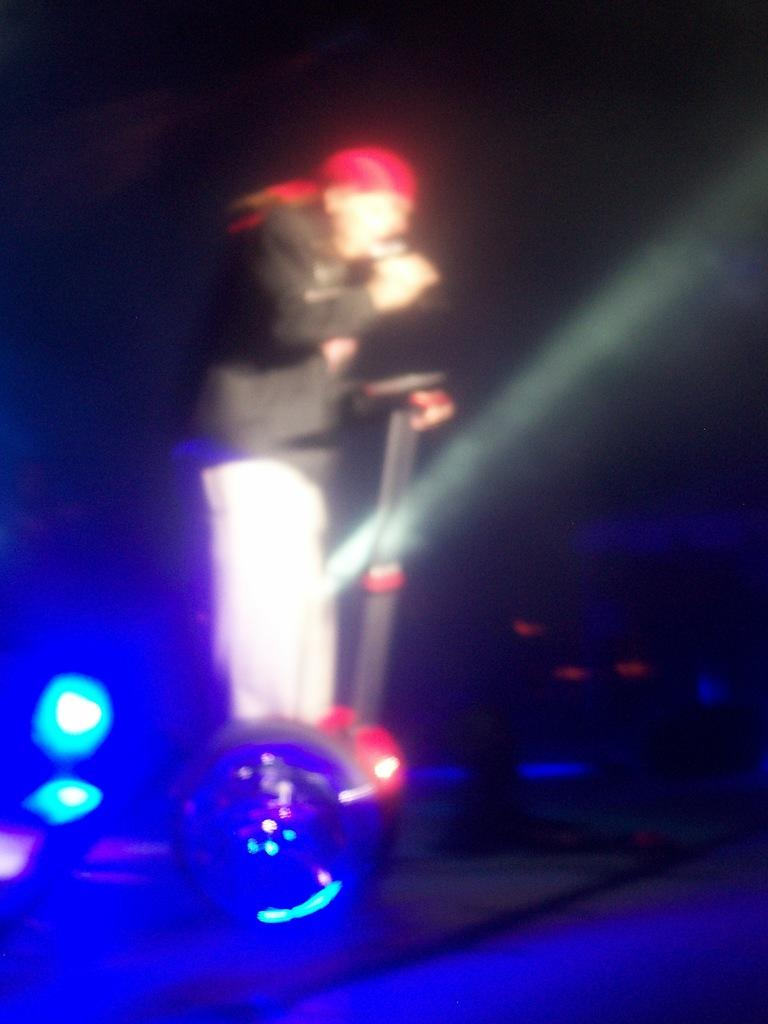What is the main subject of the image? There is a person standing on a platform in the image. What can be seen in the image besides the person on the platform? There are lights visible in the image, as well as other objects. How would you describe the overall lighting in the image? The background of the image is dark. What nation is represented by the army in the image? There is no army present in the image, so it is not possible to determine which nation might be represented. 